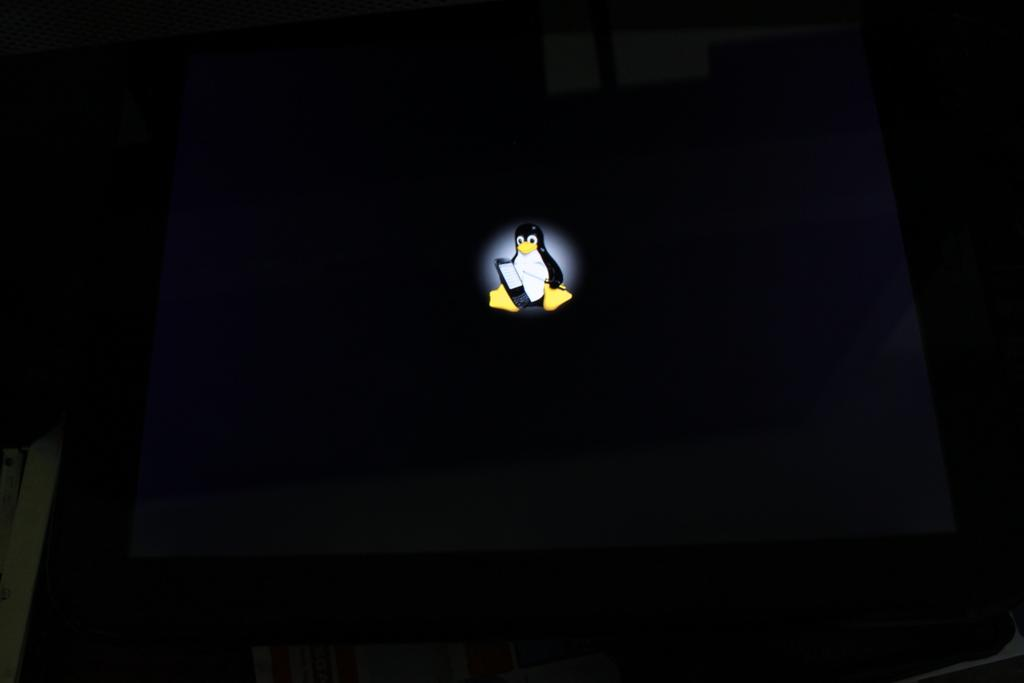What type of animal is in the image? There is a penguin in the image. What color is the penguin in the image? The penguin is black in color. What type of war is the penguin participating in the image? There is no war or any indication of conflict in the image; it features a penguin. How does the penguin slip on the ice in the image? There is no ice or any indication of the penguin slipping in the image. 